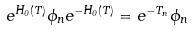Convert formula to latex. <formula><loc_0><loc_0><loc_500><loc_500>e ^ { H _ { 0 } ( { T } ) } \phi _ { n } e ^ { - H _ { 0 } ( { T } ) } = e ^ { - T _ { n } } \phi _ { n }</formula> 